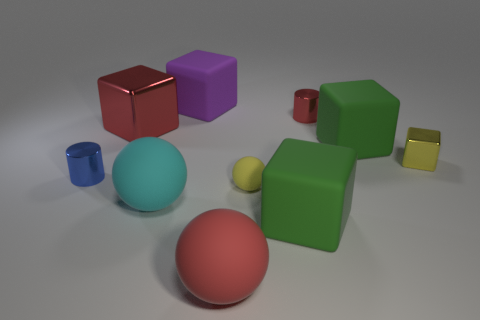Subtract 1 blocks. How many blocks are left? 4 Subtract all big red cubes. How many cubes are left? 4 Subtract all red cubes. How many cubes are left? 4 Subtract all blue balls. Subtract all green cylinders. How many balls are left? 3 Subtract all cylinders. How many objects are left? 8 Add 1 blue objects. How many blue objects exist? 2 Subtract 0 brown cubes. How many objects are left? 10 Subtract all red metal things. Subtract all matte objects. How many objects are left? 2 Add 3 cyan matte balls. How many cyan matte balls are left? 4 